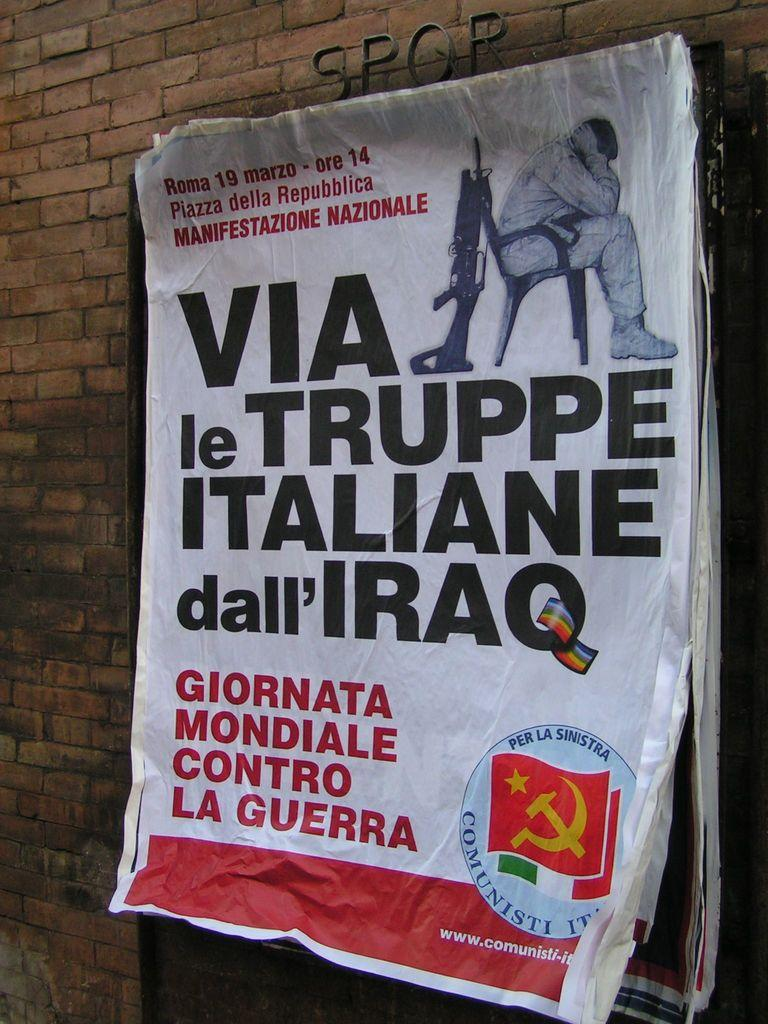<image>
Provide a brief description of the given image. The poster on the building says "VIA le TRUPPE ITALIANE dall'IRAQ. 